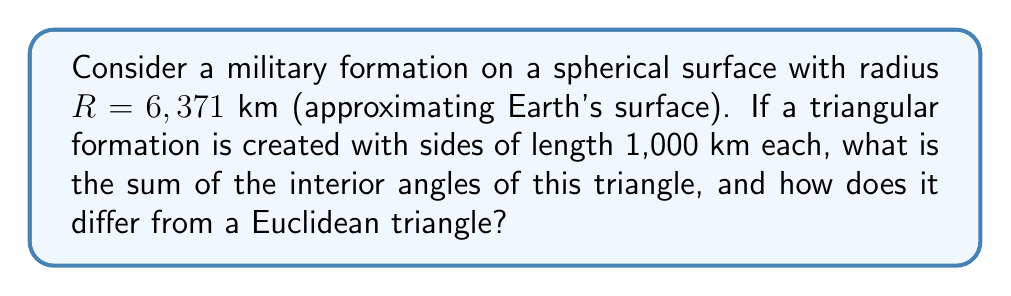Can you solve this math problem? To solve this problem, we'll use concepts from spherical geometry:

1) In spherical geometry, the sum of angles in a triangle is greater than 180°. The excess is proportional to the area of the triangle.

2) The formula for the area $A$ of a spherical triangle is:

   $$A = R^2(α + β + γ - π)$$

   where $R$ is the radius of the sphere, and $α$, $β$, and $γ$ are the angles of the triangle in radians.

3) We need to find the angles of the triangle. In a spherical triangle with equal sides (equilateral), all angles are equal. Let's call this angle $θ$.

4) The relationship between side length $a$ and angle $θ$ in a spherical equilateral triangle is:

   $$\cos(\frac{a}{R}) = \frac{\cos(θ)}{\cos^2(\frac{θ}{2})}$$

5) Substituting our values:

   $$\cos(\frac{1000}{6371}) = \frac{\cos(θ)}{\cos^2(\frac{θ}{2})}$$

6) Solving this equation numerically (as it's transcendental), we get:

   $$θ ≈ 0.5805 \text{ radians} ≈ 33.27°$$

7) The sum of angles is thus:

   $$3θ ≈ 3 * 33.27° = 99.81°$$

8) Converting to radians:

   $$99.81° * \frac{π}{180°} ≈ 1.7421 \text{ radians}$$

9) The excess over π (180°) is:

   $$1.7421 - π ≈ 0.0005 \text{ radians} ≈ 0.0286°$$

This excess represents the curvature's effect on the formation, causing the sum of angles to be greater than in a Euclidean triangle.
Answer: $$99.81°$$, exceeding 180° by $$0.0286°$$ due to Earth's curvature. 